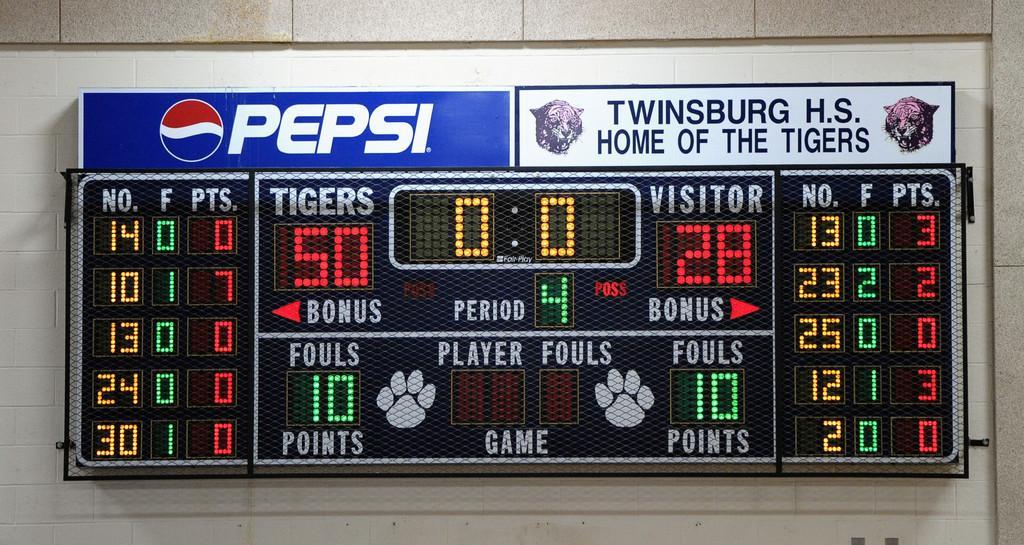Please provide a concise description of this image. In this image I can see a screen and I can see few numbers and something is written on it. The screen is attached to the white color wall. Back I can see white and blue color board attached to the wall. 